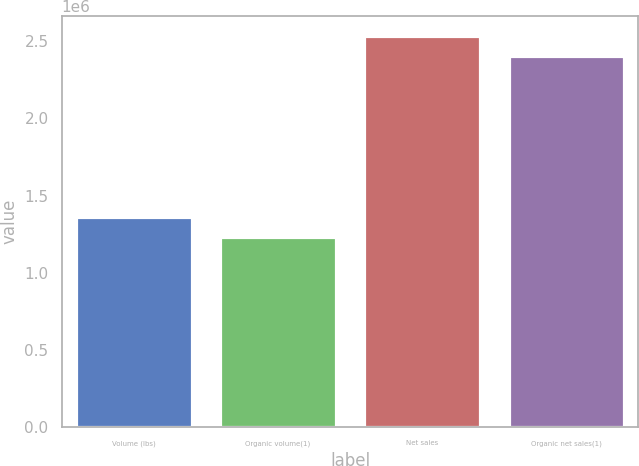<chart> <loc_0><loc_0><loc_500><loc_500><bar_chart><fcel>Volume (lbs)<fcel>Organic volume(1)<fcel>Net sales<fcel>Organic net sales(1)<nl><fcel>1.36192e+06<fcel>1.23273e+06<fcel>2.5366e+06<fcel>2.4074e+06<nl></chart> 